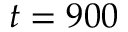<formula> <loc_0><loc_0><loc_500><loc_500>t = 9 0 0</formula> 